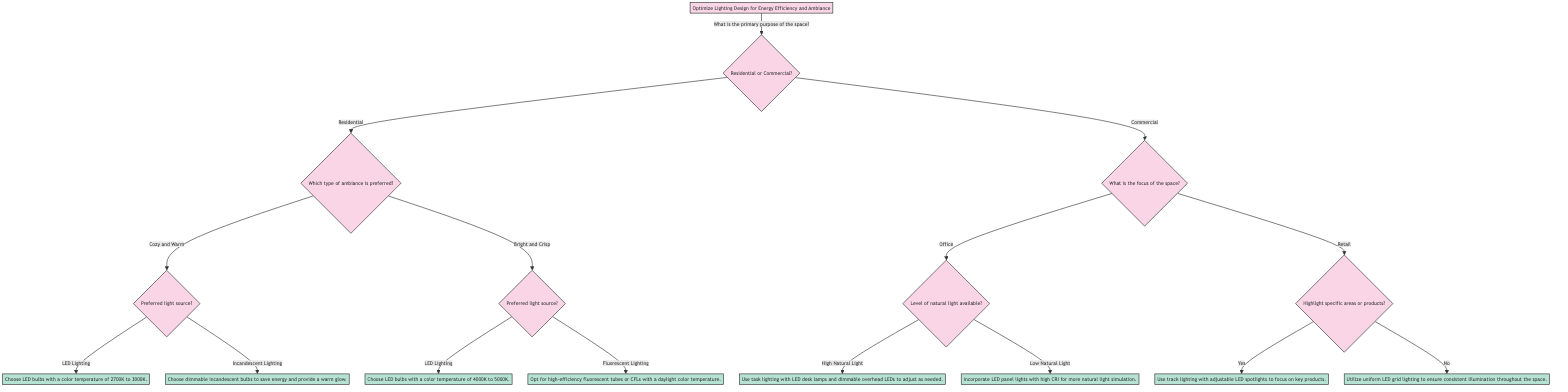What is the primary goal of the diagram? The primary goal is stated at the top of the decision tree as "Optimize Lighting Design for Energy Efficiency and Ambiance."
Answer: Optimize Lighting Design for Energy Efficiency and Ambiance How many main branches are there for the primary purpose of the space? There are two main branches: Residential and Commercial. The question directly splits into these two options.
Answer: 2 What action is suggested if the space's ambiance is "Bright and Crisp" with "LED Lighting"? After following the path for "Bright and Crisp" and selecting "LED Lighting," the action suggested is to "Choose LED bulbs with a color temperature of 4000K to 5000K."
Answer: Choose LED bulbs with a color temperature of 4000K to 5000K What is the recommended action for "Low Natural Light" in an Office space? The path from "Commercial" to "Office" leads to the question about natural light, and selecting "Low Natural Light" directs the flow to "Incorporate LED panel lights with high CRI for more natural light simulation."
Answer: Incorporate LED panel lights with high CRI for more natural light simulation What happens if a Retail space does not highlight specific areas or products? If the selection is "Retail" and then "No" for highlighting areas or products, the action is to "Utilize uniform LED grid lighting to ensure consistent illumination throughout the space."
Answer: Utilize uniform LED grid lighting to ensure consistent illumination throughout the space Which ambiance option is associated with "Incandescent Lighting"? Following the branch for Residential, selecting "Cozy and Warm" leads directly to the option of "Incandescent Lighting," which suggests choosing dimmable incandescent bulbs.
Answer: Cozy and Warm What is the output if the primary purpose of the space is defined as "Residential" and the preferred ambiance is "Cozy and Warm"? The flow from "Residential" to "Cozy and Warm" leads to the next question about the preferred light source. Depending on the chosen source (either LED or incandescent), it will provide specific actions regarding the type of bulbs to use. Both paths provide different actions based on the light source.
Answer: Choose LED bulbs with a color temperature of 2700K to 3000K or Choose dimmable incandescent bulbs to save energy and provide a warm glow How is the ambiance for a Commercial space's Office category impacted by the level of natural light? The decision tree branches from Commercial to Office, then asks about natural light availability. Selecting "High Natural Light" suggests one action for task lighting, while "Low Natural Light" leads to a different action focusing on LED panel lights. This indicates different strategies based on the level of natural light present.
Answer: Different strategies for High and Low Natural Light 